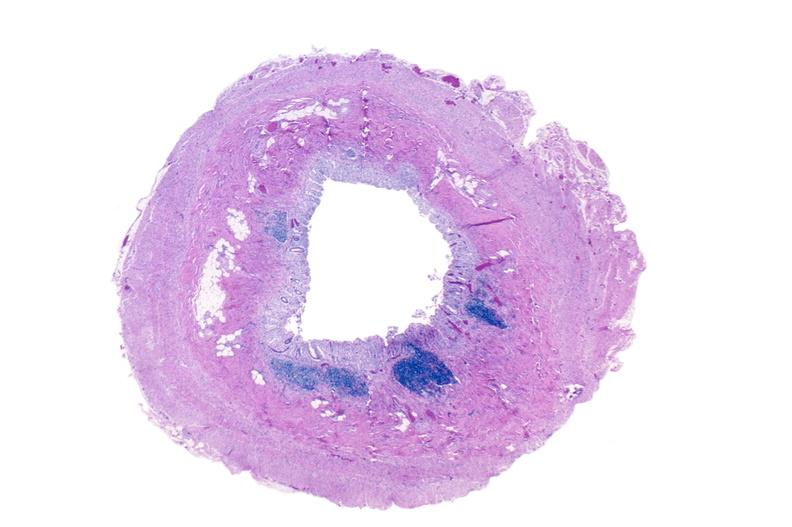what is present?
Answer the question using a single word or phrase. Gastrointestinal 